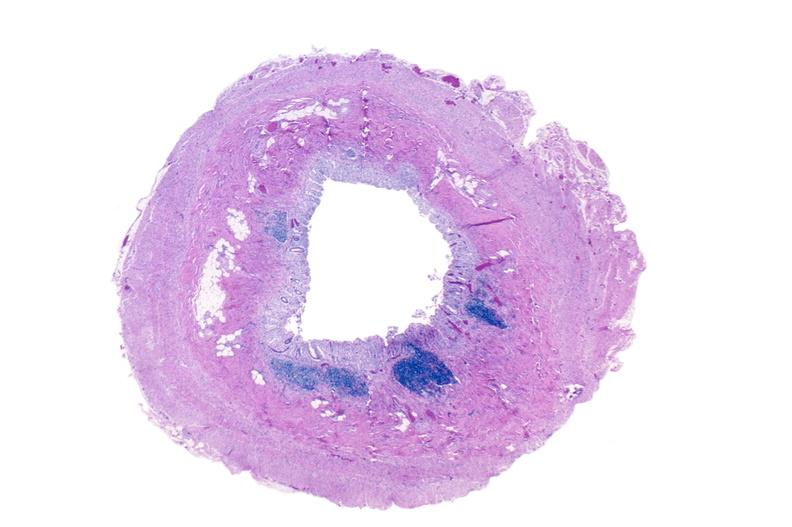what is present?
Answer the question using a single word or phrase. Gastrointestinal 